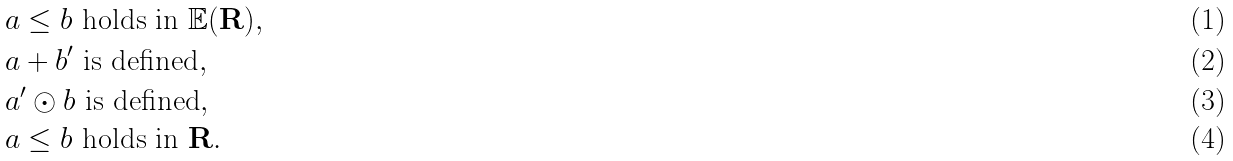Convert formula to latex. <formula><loc_0><loc_0><loc_500><loc_500>& a \leq b \text { holds in } \mathbb { E } ( \mathbf R ) , \\ & a + b ^ { \prime } \text { is defined} , \\ & a ^ { \prime } \odot b \text { is defined} , \\ & a \leq b \text { holds in } \mathbf R .</formula> 